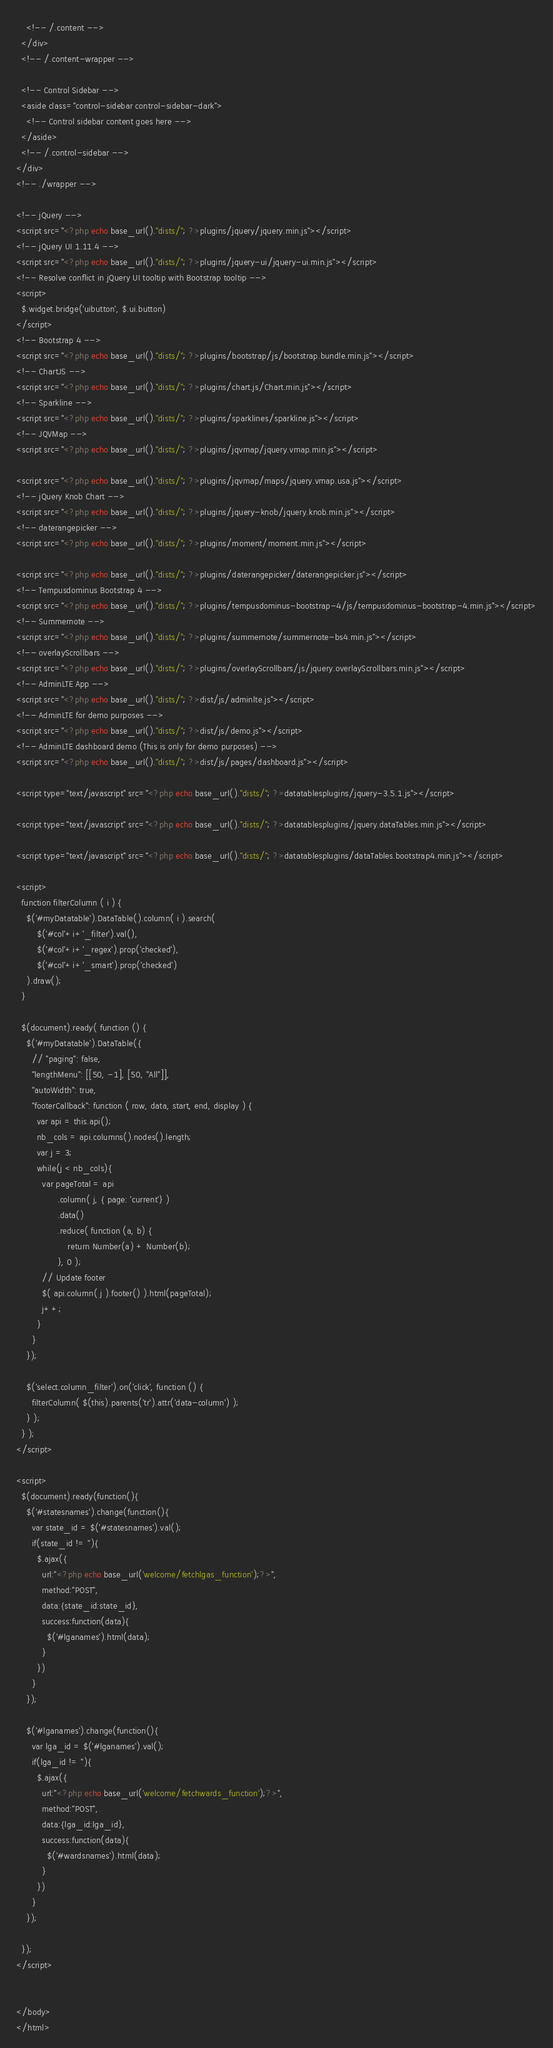<code> <loc_0><loc_0><loc_500><loc_500><_PHP_>    <!-- /.content -->
  </div>
  <!-- /.content-wrapper -->

  <!-- Control Sidebar -->
  <aside class="control-sidebar control-sidebar-dark">
    <!-- Control sidebar content goes here -->
  </aside>
  <!-- /.control-sidebar -->
</div>
<!-- ./wrapper -->

<!-- jQuery -->
<script src="<?php echo base_url()."dists/"; ?>plugins/jquery/jquery.min.js"></script>
<!-- jQuery UI 1.11.4 -->
<script src="<?php echo base_url()."dists/"; ?>plugins/jquery-ui/jquery-ui.min.js"></script>
<!-- Resolve conflict in jQuery UI tooltip with Bootstrap tooltip -->
<script>
  $.widget.bridge('uibutton', $.ui.button)
</script>
<!-- Bootstrap 4 -->
<script src="<?php echo base_url()."dists/"; ?>plugins/bootstrap/js/bootstrap.bundle.min.js"></script>
<!-- ChartJS -->
<script src="<?php echo base_url()."dists/"; ?>plugins/chart.js/Chart.min.js"></script>
<!-- Sparkline -->
<script src="<?php echo base_url()."dists/"; ?>plugins/sparklines/sparkline.js"></script>
<!-- JQVMap -->
<script src="<?php echo base_url()."dists/"; ?>plugins/jqvmap/jquery.vmap.min.js"></script>

<script src="<?php echo base_url()."dists/"; ?>plugins/jqvmap/maps/jquery.vmap.usa.js"></script>
<!-- jQuery Knob Chart -->
<script src="<?php echo base_url()."dists/"; ?>plugins/jquery-knob/jquery.knob.min.js"></script>
<!-- daterangepicker -->
<script src="<?php echo base_url()."dists/"; ?>plugins/moment/moment.min.js"></script>

<script src="<?php echo base_url()."dists/"; ?>plugins/daterangepicker/daterangepicker.js"></script>
<!-- Tempusdominus Bootstrap 4 -->
<script src="<?php echo base_url()."dists/"; ?>plugins/tempusdominus-bootstrap-4/js/tempusdominus-bootstrap-4.min.js"></script>
<!-- Summernote -->
<script src="<?php echo base_url()."dists/"; ?>plugins/summernote/summernote-bs4.min.js"></script>
<!-- overlayScrollbars -->
<script src="<?php echo base_url()."dists/"; ?>plugins/overlayScrollbars/js/jquery.overlayScrollbars.min.js"></script>
<!-- AdminLTE App -->
<script src="<?php echo base_url()."dists/"; ?>dist/js/adminlte.js"></script>
<!-- AdminLTE for demo purposes -->
<script src="<?php echo base_url()."dists/"; ?>dist/js/demo.js"></script>
<!-- AdminLTE dashboard demo (This is only for demo purposes) -->
<script src="<?php echo base_url()."dists/"; ?>dist/js/pages/dashboard.js"></script>

<script type="text/javascript" src="<?php echo base_url()."dists/"; ?>datatablesplugins/jquery-3.5.1.js"></script>

<script type="text/javascript" src="<?php echo base_url()."dists/"; ?>datatablesplugins/jquery.dataTables.min.js"></script>

<script type="text/javascript" src="<?php echo base_url()."dists/"; ?>datatablesplugins/dataTables.bootstrap4.min.js"></script>

<script>
  function filterColumn ( i ) {
    $('#myDatatable').DataTable().column( i ).search(
        $('#col'+i+'_filter').val(),
        $('#col'+i+'_regex').prop('checked'),
        $('#col'+i+'_smart').prop('checked')
    ).draw();
  }

  $(document).ready( function () {
    $('#myDatatable').DataTable({
      // "paging": false,
      "lengthMenu": [[50, -1], [50, "All"]],
      "autoWidth": true,
      "footerCallback": function ( row, data, start, end, display ) {
        var api = this.api();
        nb_cols = api.columns().nodes().length;
        var j = 3;
        while(j < nb_cols){
          var pageTotal = api
                .column( j, { page: 'current'} )
                .data()
                .reduce( function (a, b) {
                    return Number(a) + Number(b);
                }, 0 );
          // Update footer
          $( api.column( j ).footer() ).html(pageTotal);
          j++;
        } 
      }
    });

    $('select.column_filter').on('click', function () {
      filterColumn( $(this).parents('tr').attr('data-column') );
    } );
  } );
</script>

<script>
  $(document).ready(function(){
    $('#statesnames').change(function(){
      var state_id = $('#statesnames').val();
      if(state_id != ''){
        $.ajax({
          url:"<?php echo base_url('welcome/fetchlgas_function');?>",
          method:"POST",
          data:{state_id:state_id},
          success:function(data){
            $('#lganames').html(data);
          }
        })
      }
    });

    $('#lganames').change(function(){
      var lga_id = $('#lganames').val();
      if(lga_id != ''){
        $.ajax({
          url:"<?php echo base_url('welcome/fetchwards_function');?>",
          method:"POST",
          data:{lga_id:lga_id},
          success:function(data){
            $('#wardsnames').html(data);
          }
        })
      }
    });

  });
</script>


</body>
</html>
</code> 